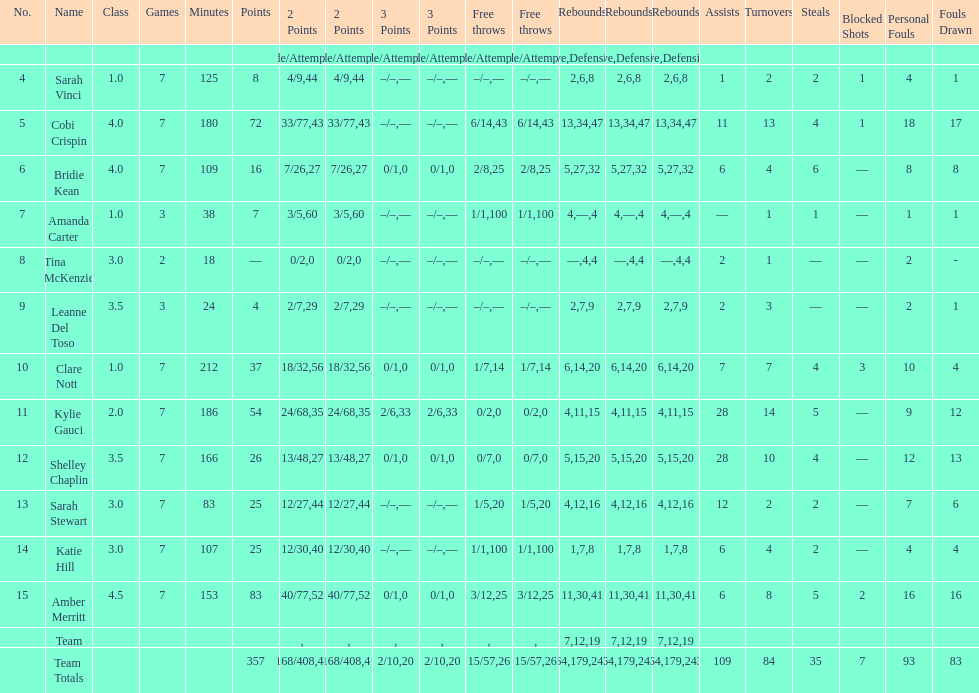Alongside merritt, who was the leading scorer? Cobi Crispin. 